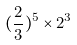Convert formula to latex. <formula><loc_0><loc_0><loc_500><loc_500>( \frac { 2 } { 3 } ) ^ { 5 } \times 2 ^ { 3 }</formula> 